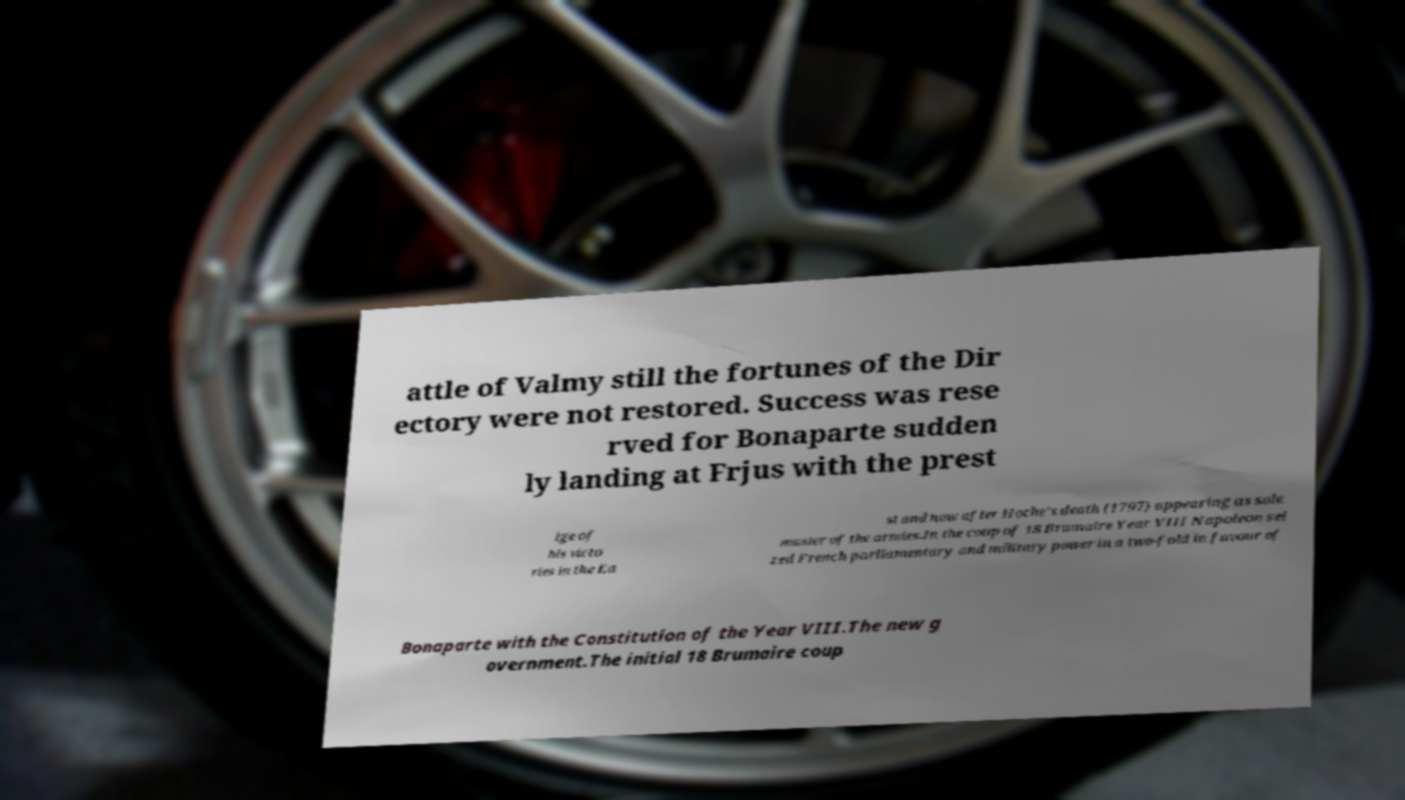There's text embedded in this image that I need extracted. Can you transcribe it verbatim? attle of Valmy still the fortunes of the Dir ectory were not restored. Success was rese rved for Bonaparte sudden ly landing at Frjus with the prest ige of his victo ries in the Ea st and now after Hoche's death (1797) appearing as sole master of the armies.In the coup of 18 Brumaire Year VIII Napoleon sei zed French parliamentary and military power in a two-fold in favour of Bonaparte with the Constitution of the Year VIII.The new g overnment.The initial 18 Brumaire coup 